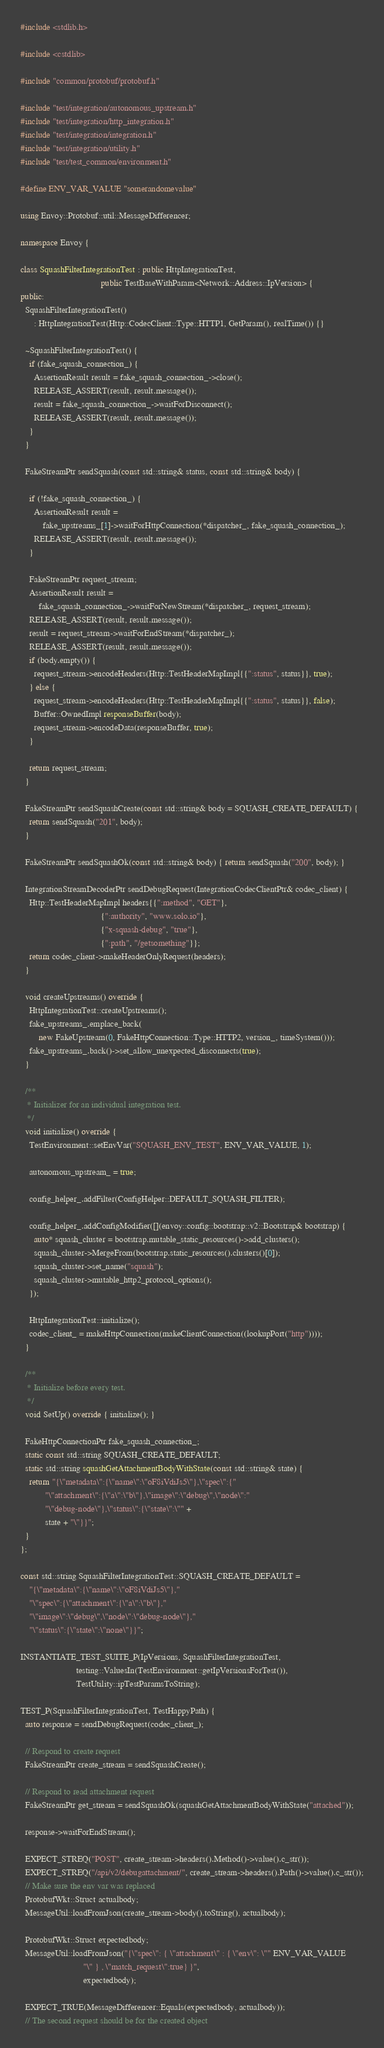Convert code to text. <code><loc_0><loc_0><loc_500><loc_500><_C++_>#include <stdlib.h>

#include <cstdlib>

#include "common/protobuf/protobuf.h"

#include "test/integration/autonomous_upstream.h"
#include "test/integration/http_integration.h"
#include "test/integration/integration.h"
#include "test/integration/utility.h"
#include "test/test_common/environment.h"

#define ENV_VAR_VALUE "somerandomevalue"

using Envoy::Protobuf::util::MessageDifferencer;

namespace Envoy {

class SquashFilterIntegrationTest : public HttpIntegrationTest,
                                    public TestBaseWithParam<Network::Address::IpVersion> {
public:
  SquashFilterIntegrationTest()
      : HttpIntegrationTest(Http::CodecClient::Type::HTTP1, GetParam(), realTime()) {}

  ~SquashFilterIntegrationTest() {
    if (fake_squash_connection_) {
      AssertionResult result = fake_squash_connection_->close();
      RELEASE_ASSERT(result, result.message());
      result = fake_squash_connection_->waitForDisconnect();
      RELEASE_ASSERT(result, result.message());
    }
  }

  FakeStreamPtr sendSquash(const std::string& status, const std::string& body) {

    if (!fake_squash_connection_) {
      AssertionResult result =
          fake_upstreams_[1]->waitForHttpConnection(*dispatcher_, fake_squash_connection_);
      RELEASE_ASSERT(result, result.message());
    }

    FakeStreamPtr request_stream;
    AssertionResult result =
        fake_squash_connection_->waitForNewStream(*dispatcher_, request_stream);
    RELEASE_ASSERT(result, result.message());
    result = request_stream->waitForEndStream(*dispatcher_);
    RELEASE_ASSERT(result, result.message());
    if (body.empty()) {
      request_stream->encodeHeaders(Http::TestHeaderMapImpl{{":status", status}}, true);
    } else {
      request_stream->encodeHeaders(Http::TestHeaderMapImpl{{":status", status}}, false);
      Buffer::OwnedImpl responseBuffer(body);
      request_stream->encodeData(responseBuffer, true);
    }

    return request_stream;
  }

  FakeStreamPtr sendSquashCreate(const std::string& body = SQUASH_CREATE_DEFAULT) {
    return sendSquash("201", body);
  }

  FakeStreamPtr sendSquashOk(const std::string& body) { return sendSquash("200", body); }

  IntegrationStreamDecoderPtr sendDebugRequest(IntegrationCodecClientPtr& codec_client) {
    Http::TestHeaderMapImpl headers{{":method", "GET"},
                                    {":authority", "www.solo.io"},
                                    {"x-squash-debug", "true"},
                                    {":path", "/getsomething"}};
    return codec_client->makeHeaderOnlyRequest(headers);
  }

  void createUpstreams() override {
    HttpIntegrationTest::createUpstreams();
    fake_upstreams_.emplace_back(
        new FakeUpstream(0, FakeHttpConnection::Type::HTTP2, version_, timeSystem()));
    fake_upstreams_.back()->set_allow_unexpected_disconnects(true);
  }

  /**
   * Initializer for an individual integration test.
   */
  void initialize() override {
    TestEnvironment::setEnvVar("SQUASH_ENV_TEST", ENV_VAR_VALUE, 1);

    autonomous_upstream_ = true;

    config_helper_.addFilter(ConfigHelper::DEFAULT_SQUASH_FILTER);

    config_helper_.addConfigModifier([](envoy::config::bootstrap::v2::Bootstrap& bootstrap) {
      auto* squash_cluster = bootstrap.mutable_static_resources()->add_clusters();
      squash_cluster->MergeFrom(bootstrap.static_resources().clusters()[0]);
      squash_cluster->set_name("squash");
      squash_cluster->mutable_http2_protocol_options();
    });

    HttpIntegrationTest::initialize();
    codec_client_ = makeHttpConnection(makeClientConnection((lookupPort("http"))));
  }

  /**
   * Initialize before every test.
   */
  void SetUp() override { initialize(); }

  FakeHttpConnectionPtr fake_squash_connection_;
  static const std::string SQUASH_CREATE_DEFAULT;
  static std::string squashGetAttachmentBodyWithState(const std::string& state) {
    return "{\"metadata\":{\"name\":\"oF8iVdiJs5\"},\"spec\":{"
           "\"attachment\":{\"a\":\"b\"},\"image\":\"debug\",\"node\":"
           "\"debug-node\"},\"status\":{\"state\":\"" +
           state + "\"}}";
  }
};

const std::string SquashFilterIntegrationTest::SQUASH_CREATE_DEFAULT =
    "{\"metadata\":{\"name\":\"oF8iVdiJs5\"},"
    "\"spec\":{\"attachment\":{\"a\":\"b\"},"
    "\"image\":\"debug\",\"node\":\"debug-node\"},"
    "\"status\":{\"state\":\"none\"}}";

INSTANTIATE_TEST_SUITE_P(IpVersions, SquashFilterIntegrationTest,
                         testing::ValuesIn(TestEnvironment::getIpVersionsForTest()),
                         TestUtility::ipTestParamsToString);

TEST_P(SquashFilterIntegrationTest, TestHappyPath) {
  auto response = sendDebugRequest(codec_client_);

  // Respond to create request
  FakeStreamPtr create_stream = sendSquashCreate();

  // Respond to read attachment request
  FakeStreamPtr get_stream = sendSquashOk(squashGetAttachmentBodyWithState("attached"));

  response->waitForEndStream();

  EXPECT_STREQ("POST", create_stream->headers().Method()->value().c_str());
  EXPECT_STREQ("/api/v2/debugattachment/", create_stream->headers().Path()->value().c_str());
  // Make sure the env var was replaced
  ProtobufWkt::Struct actualbody;
  MessageUtil::loadFromJson(create_stream->body().toString(), actualbody);

  ProtobufWkt::Struct expectedbody;
  MessageUtil::loadFromJson("{\"spec\": { \"attachment\" : { \"env\": \"" ENV_VAR_VALUE
                            "\" } , \"match_request\":true} }",
                            expectedbody);

  EXPECT_TRUE(MessageDifferencer::Equals(expectedbody, actualbody));
  // The second request should be for the created object</code> 